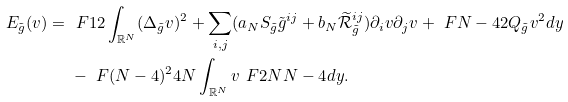<formula> <loc_0><loc_0><loc_500><loc_500>E _ { \tilde { g } } ( v ) = & \ \ F { 1 } { 2 } \int _ { \mathbb { R } ^ { N } } ( \Delta _ { \tilde { g } } v ) ^ { 2 } + \sum _ { i , j } ( a _ { N } S _ { \tilde { g } } { \tilde { g } } ^ { i j } + b _ { N } \widetilde { \mathcal { R } } _ { \tilde { g } } ^ { i j } ) \partial _ { i } v \partial _ { j } v + \ F { N - 4 } { 2 } Q _ { \tilde { g } } v ^ { 2 } d y \\ & \ - \ F { ( N - 4 ) ^ { 2 } } { 4 N } \int _ { \mathbb { R } ^ { N } } v ^ { \ } F { 2 N } { N - 4 } d y .</formula> 